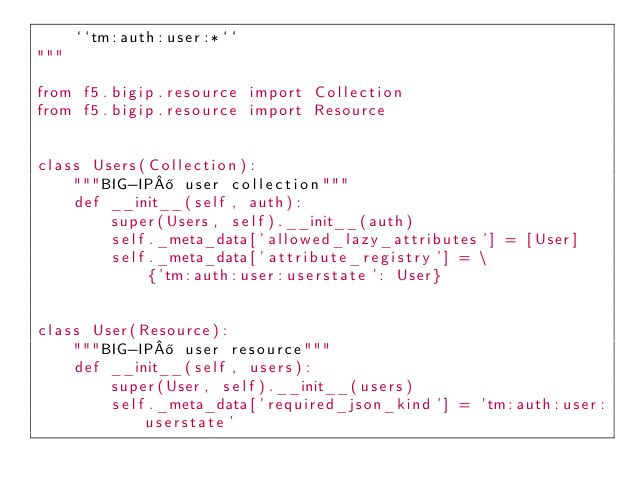Convert code to text. <code><loc_0><loc_0><loc_500><loc_500><_Python_>    ``tm:auth:user:*``
"""

from f5.bigip.resource import Collection
from f5.bigip.resource import Resource


class Users(Collection):
    """BIG-IP® user collection"""
    def __init__(self, auth):
        super(Users, self).__init__(auth)
        self._meta_data['allowed_lazy_attributes'] = [User]
        self._meta_data['attribute_registry'] = \
            {'tm:auth:user:userstate': User}


class User(Resource):
    """BIG-IP® user resource"""
    def __init__(self, users):
        super(User, self).__init__(users)
        self._meta_data['required_json_kind'] = 'tm:auth:user:userstate'
</code> 